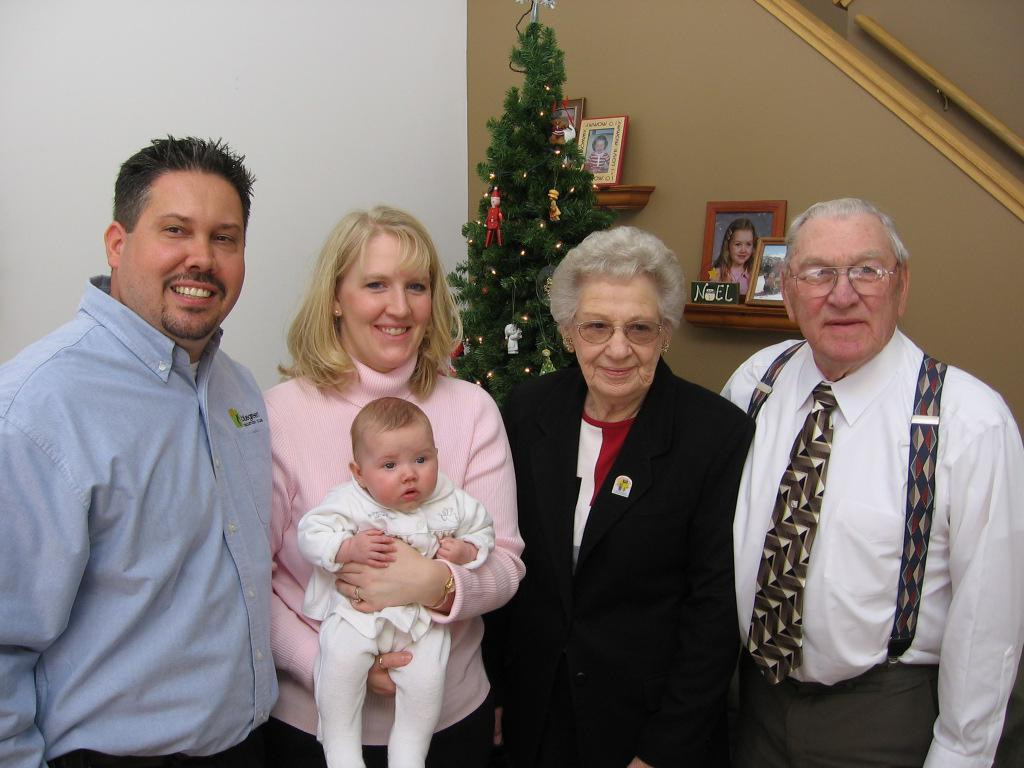What are the people in the image doing? The people in the image are standing and smiling. Can you describe the person holding an object in the image? One person is holding a baby in the image. What can be seen in the background of the image? There is a wall in the background of the image, and there are frames on the wall. What seasonal decoration is present in the image? There is a Christmas tree in the image. What verse can be seen on the calendar in the image? There is no calendar present in the image, so no verse can be seen. 